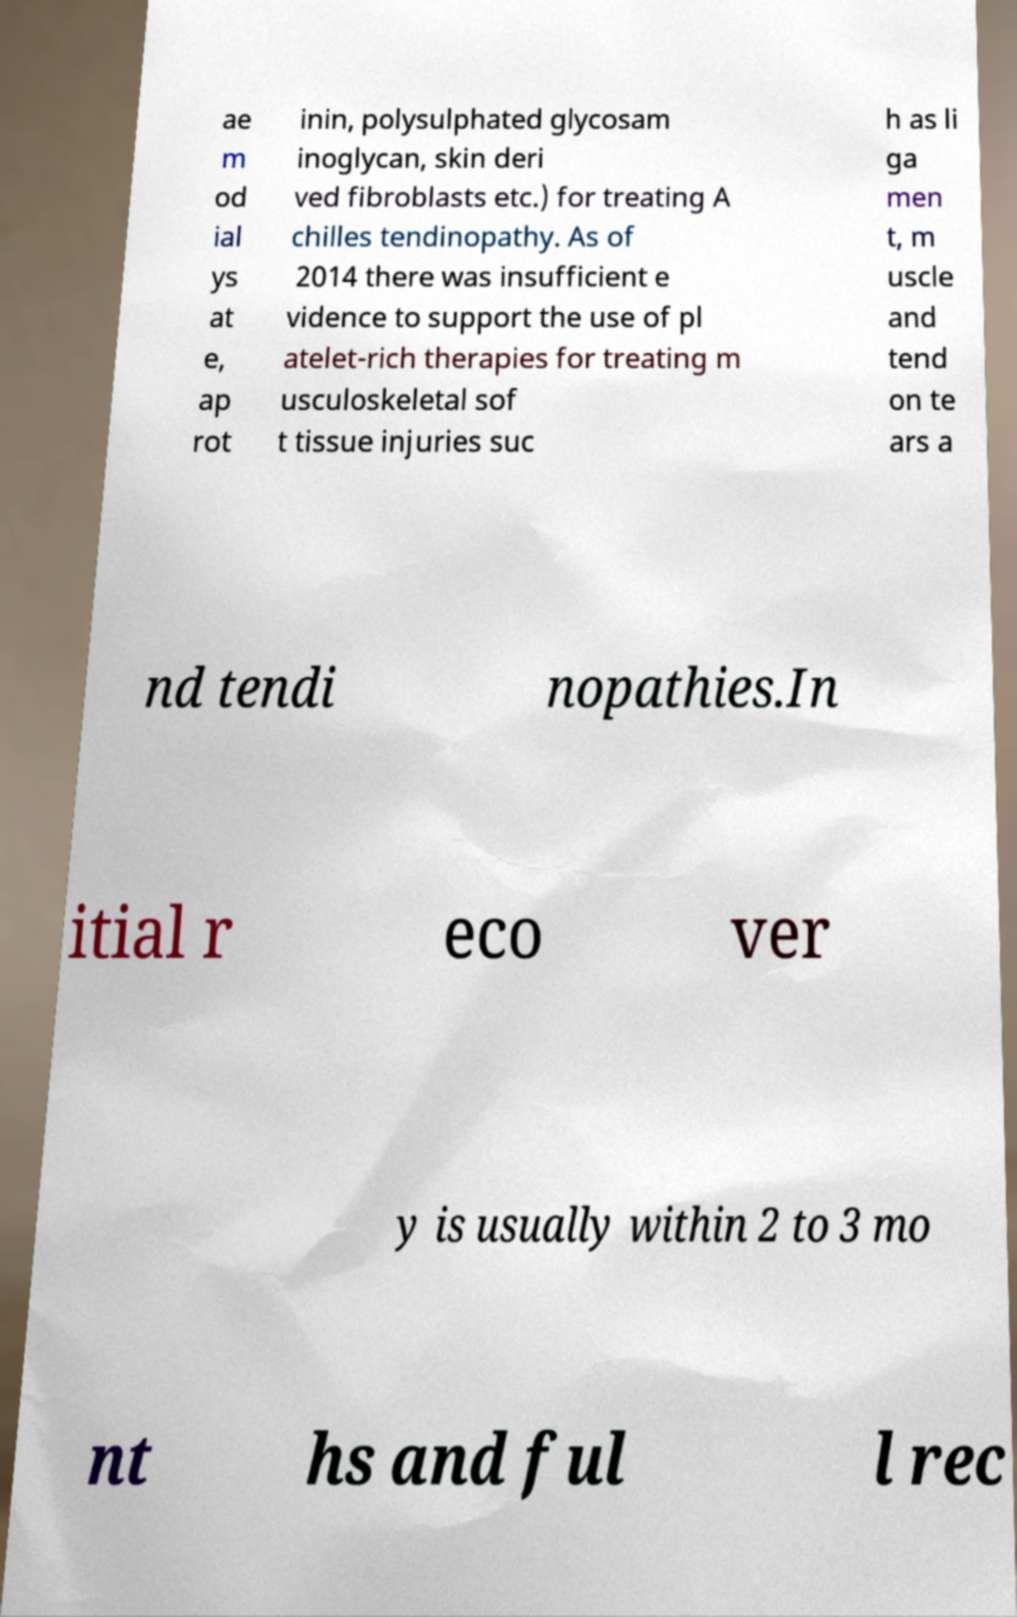Can you read and provide the text displayed in the image?This photo seems to have some interesting text. Can you extract and type it out for me? ae m od ial ys at e, ap rot inin, polysulphated glycosam inoglycan, skin deri ved fibroblasts etc.) for treating A chilles tendinopathy. As of 2014 there was insufficient e vidence to support the use of pl atelet-rich therapies for treating m usculoskeletal sof t tissue injuries suc h as li ga men t, m uscle and tend on te ars a nd tendi nopathies.In itial r eco ver y is usually within 2 to 3 mo nt hs and ful l rec 